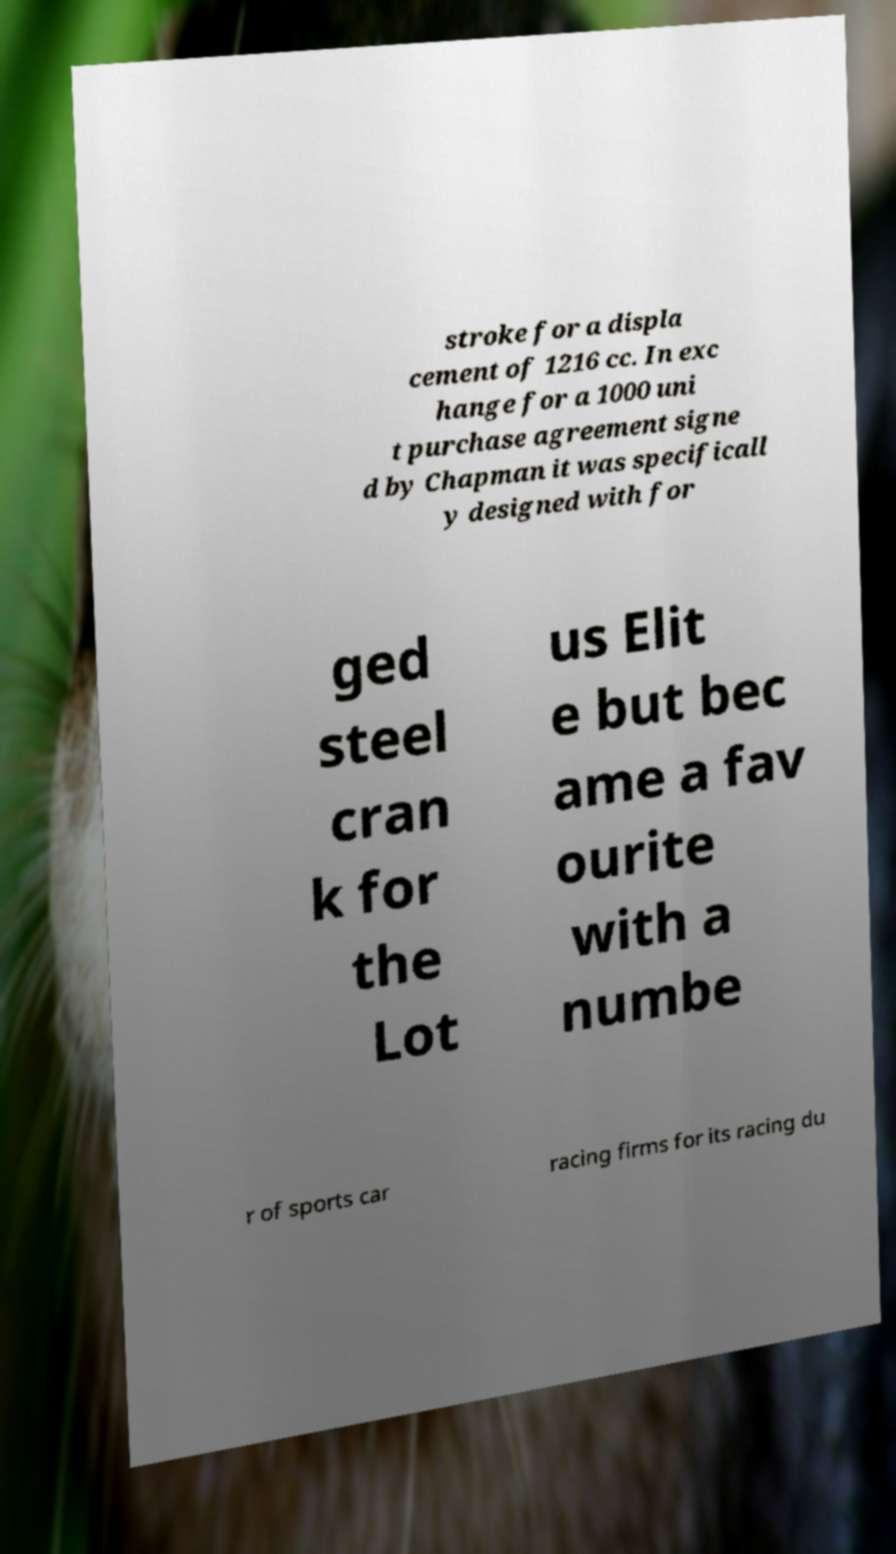Can you read and provide the text displayed in the image?This photo seems to have some interesting text. Can you extract and type it out for me? stroke for a displa cement of 1216 cc. In exc hange for a 1000 uni t purchase agreement signe d by Chapman it was specificall y designed with for ged steel cran k for the Lot us Elit e but bec ame a fav ourite with a numbe r of sports car racing firms for its racing du 